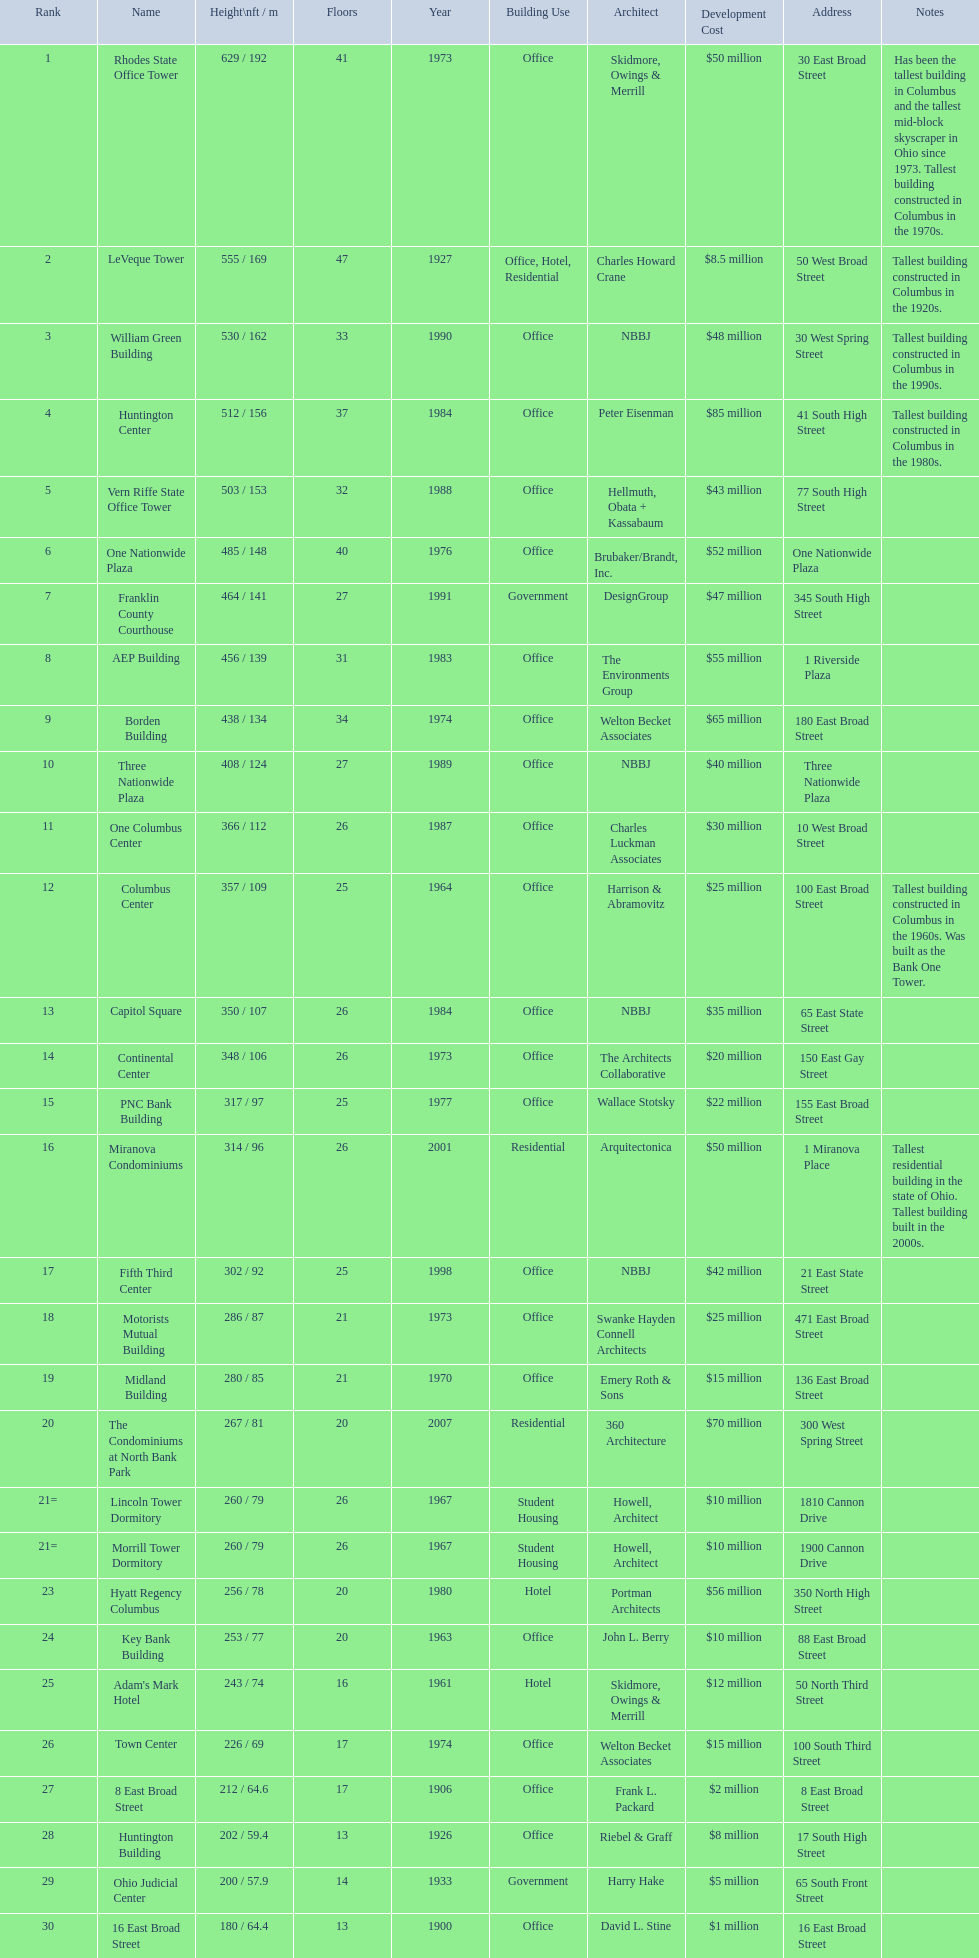Which of the tallest buildings in columbus, ohio were built in the 1980s? Huntington Center, Vern Riffe State Office Tower, AEP Building, Three Nationwide Plaza, One Columbus Center, Capitol Square, Hyatt Regency Columbus. Of these buildings, which have between 26 and 31 floors? AEP Building, Three Nationwide Plaza, One Columbus Center, Capitol Square. Of these buildings, which is the tallest? AEP Building. 